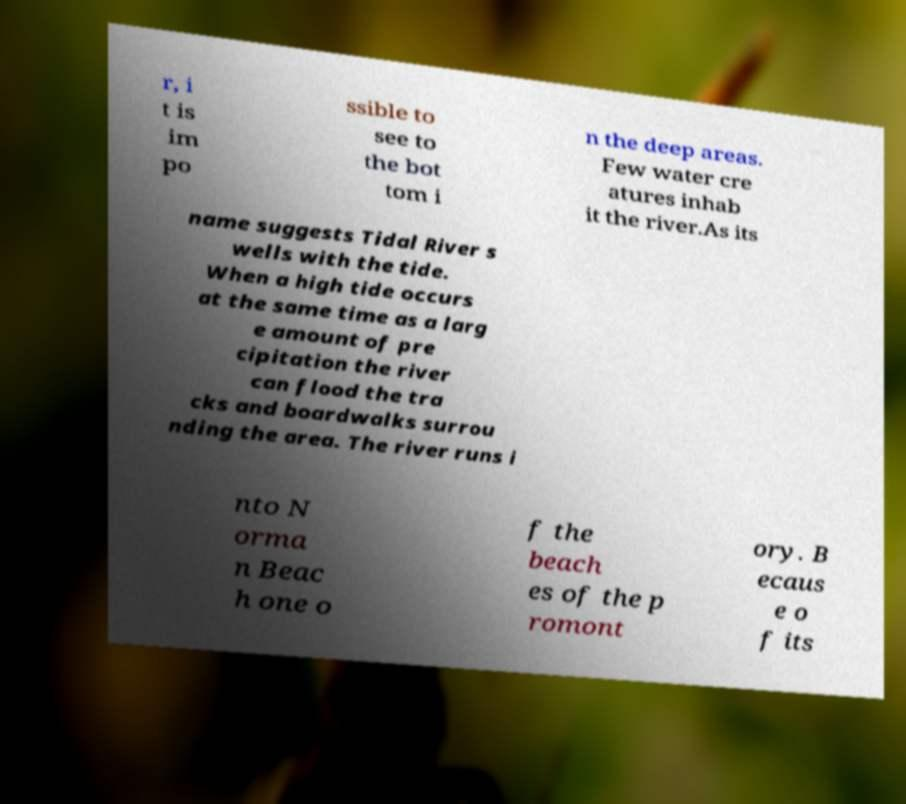Please read and relay the text visible in this image. What does it say? r, i t is im po ssible to see to the bot tom i n the deep areas. Few water cre atures inhab it the river.As its name suggests Tidal River s wells with the tide. When a high tide occurs at the same time as a larg e amount of pre cipitation the river can flood the tra cks and boardwalks surrou nding the area. The river runs i nto N orma n Beac h one o f the beach es of the p romont ory. B ecaus e o f its 